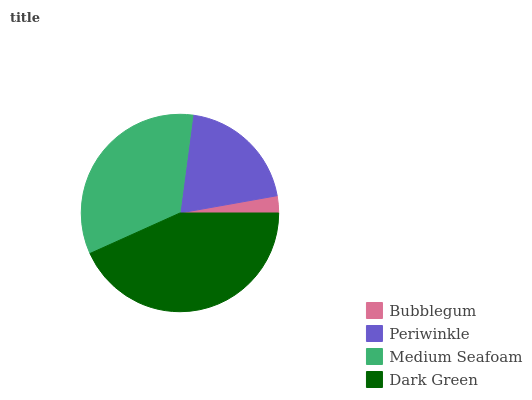Is Bubblegum the minimum?
Answer yes or no. Yes. Is Dark Green the maximum?
Answer yes or no. Yes. Is Periwinkle the minimum?
Answer yes or no. No. Is Periwinkle the maximum?
Answer yes or no. No. Is Periwinkle greater than Bubblegum?
Answer yes or no. Yes. Is Bubblegum less than Periwinkle?
Answer yes or no. Yes. Is Bubblegum greater than Periwinkle?
Answer yes or no. No. Is Periwinkle less than Bubblegum?
Answer yes or no. No. Is Medium Seafoam the high median?
Answer yes or no. Yes. Is Periwinkle the low median?
Answer yes or no. Yes. Is Bubblegum the high median?
Answer yes or no. No. Is Dark Green the low median?
Answer yes or no. No. 